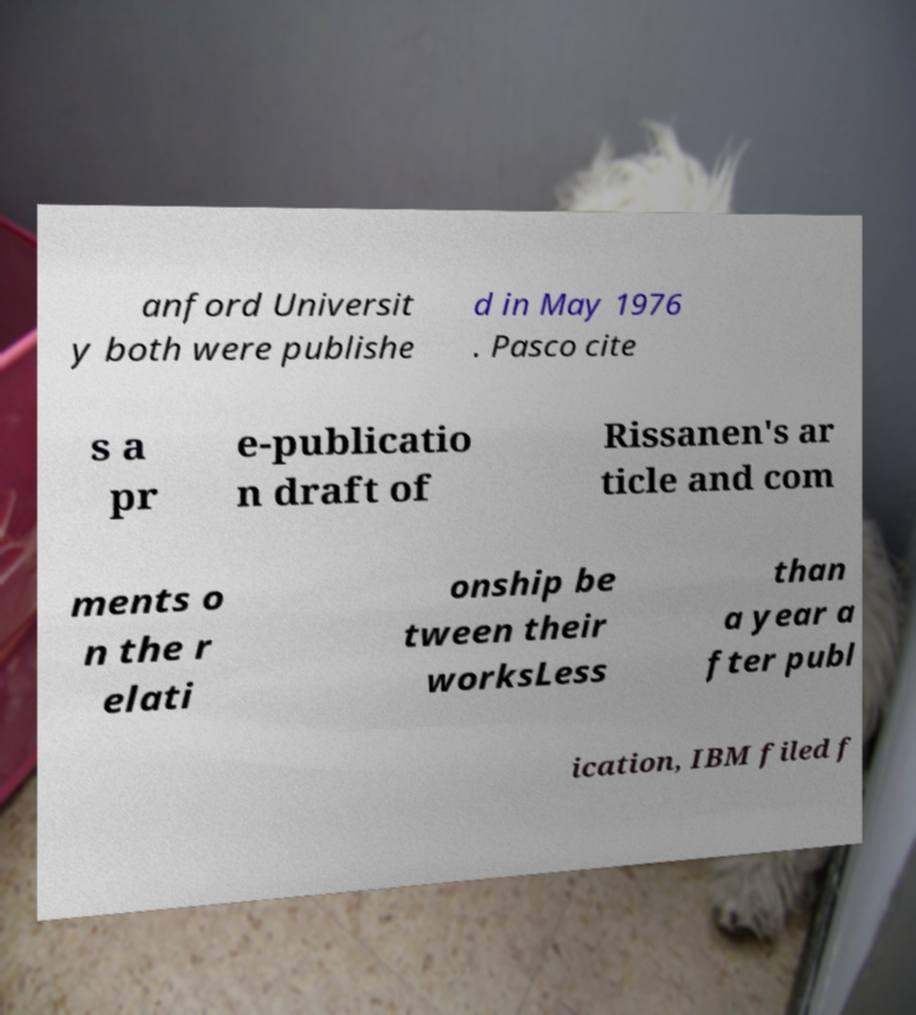What messages or text are displayed in this image? I need them in a readable, typed format. anford Universit y both were publishe d in May 1976 . Pasco cite s a pr e-publicatio n draft of Rissanen's ar ticle and com ments o n the r elati onship be tween their worksLess than a year a fter publ ication, IBM filed f 